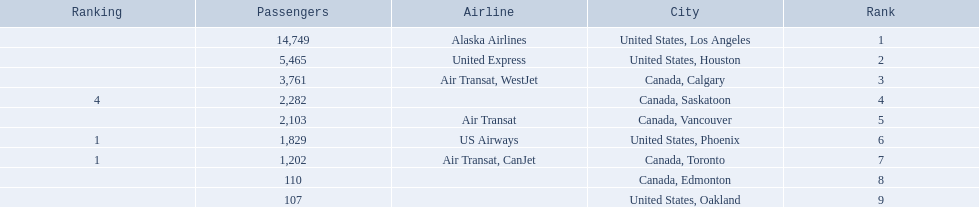Which airport has the least amount of passengers? 107. What airport has 107 passengers? United States, Oakland. 